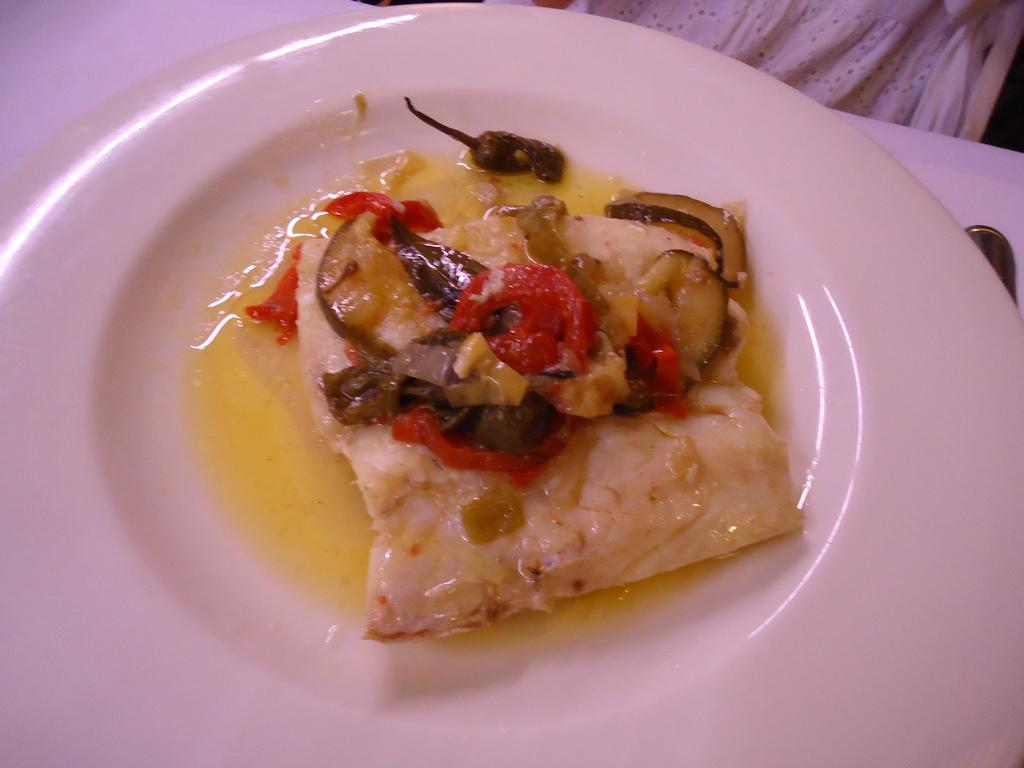What is on the plate that is visible in the image? There is a plate with food in the image. Where is the plate located in the image? The plate is placed on a table. What utensil is beside the plate in the image? There is a spoon beside the plate in the image. What can be seen at the top of the image? There is a white cloth at the top of the image. How many sticks are used to create the spring in the image? There is no spring or sticks present in the image. 